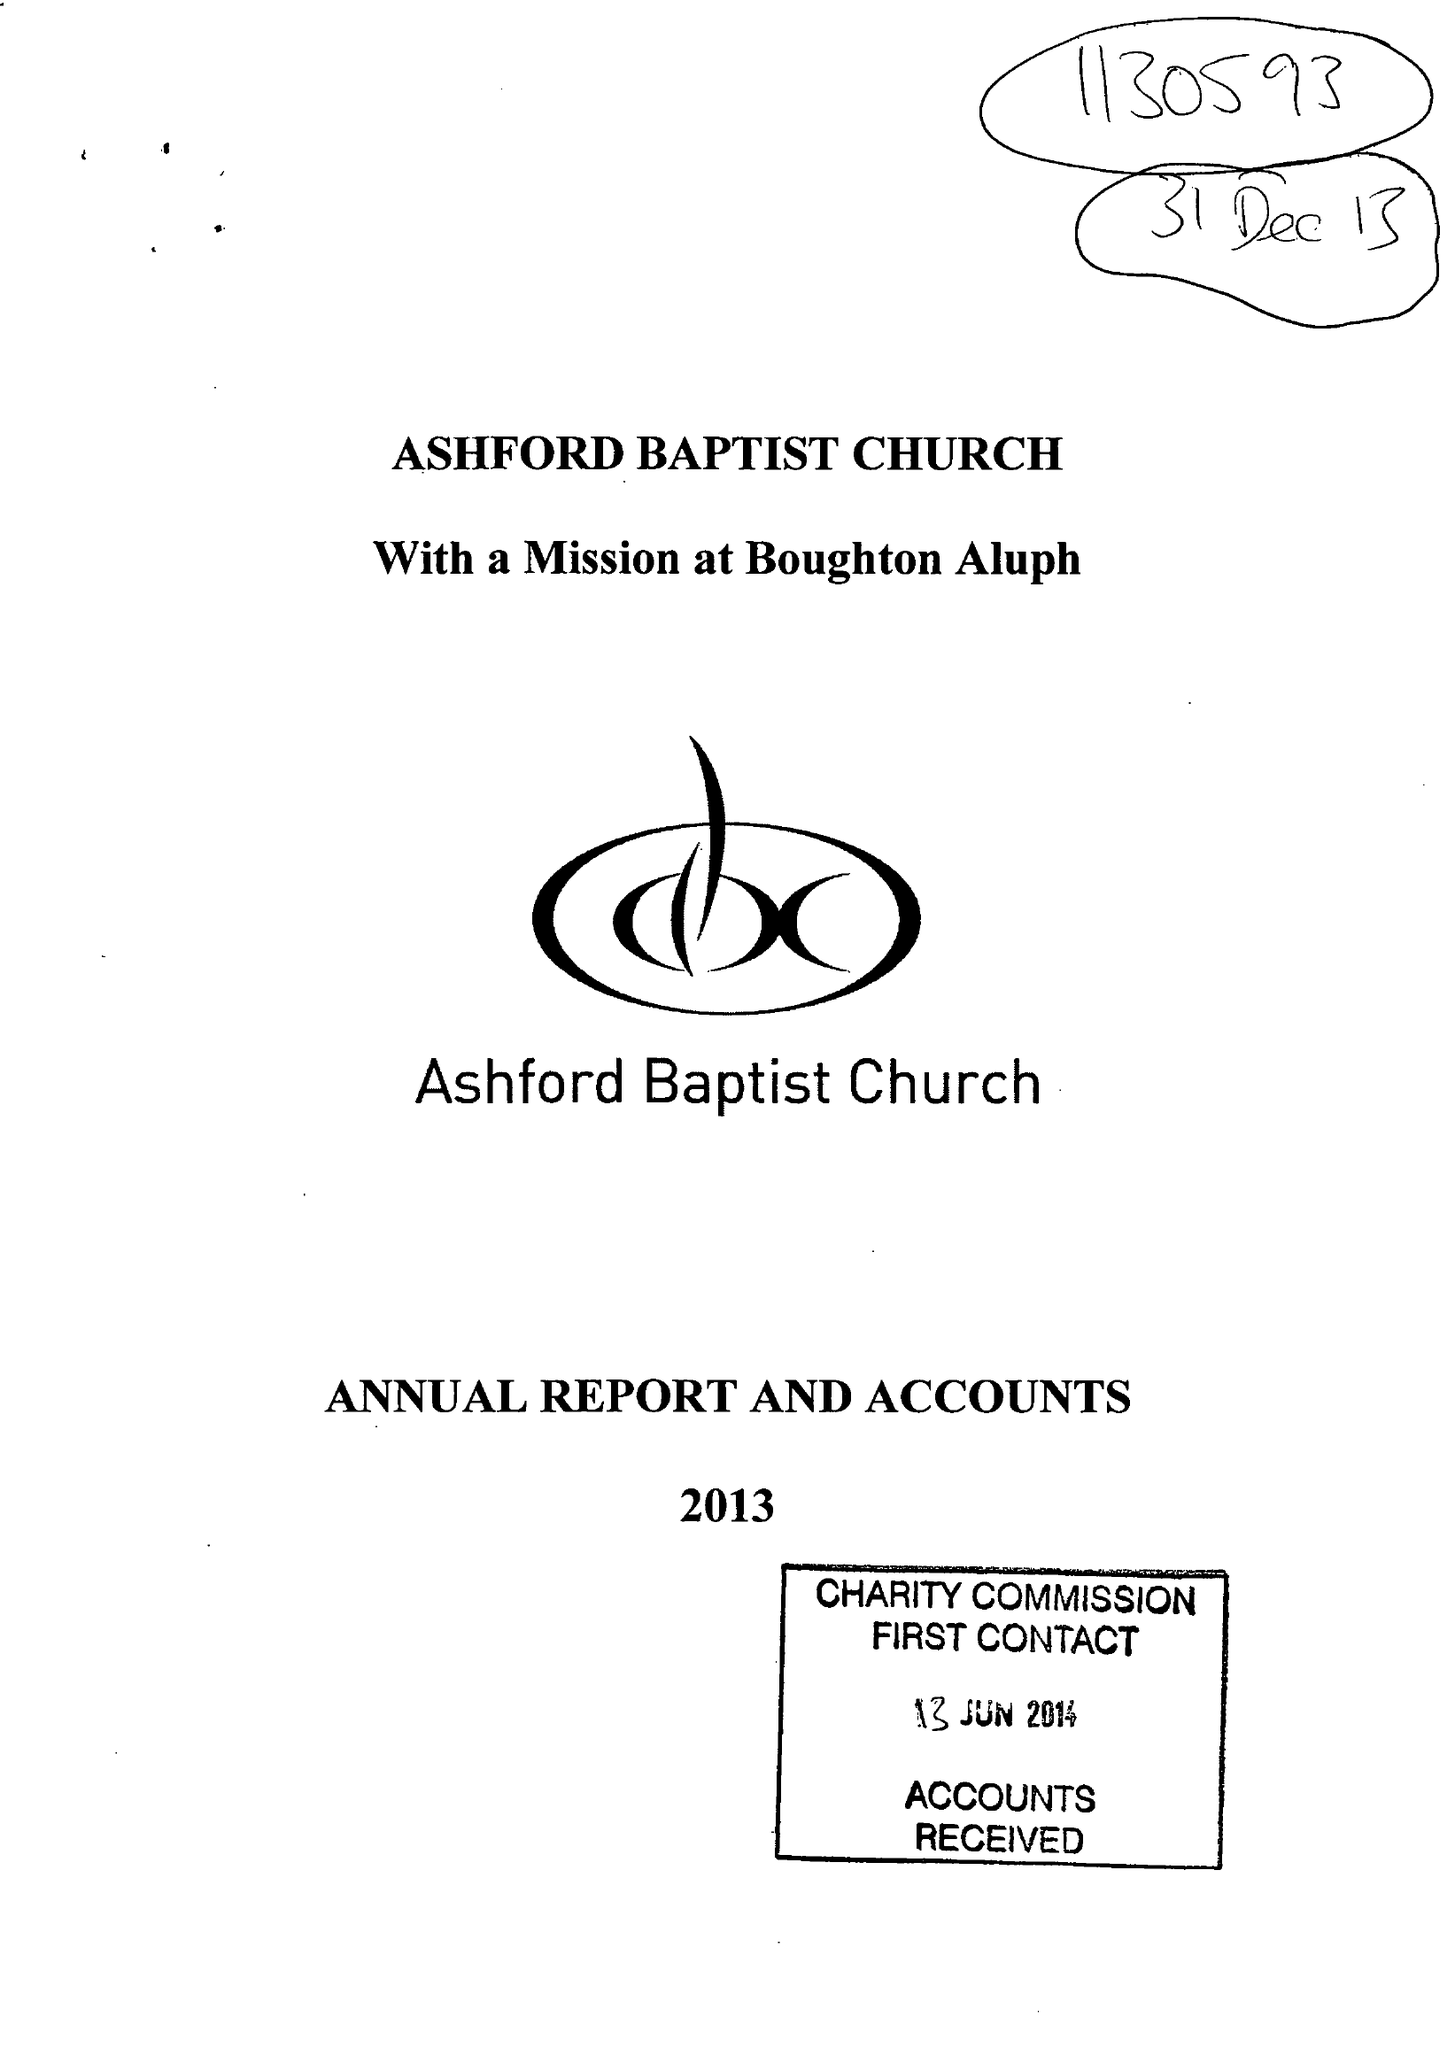What is the value for the address__post_town?
Answer the question using a single word or phrase. ASHFORD 